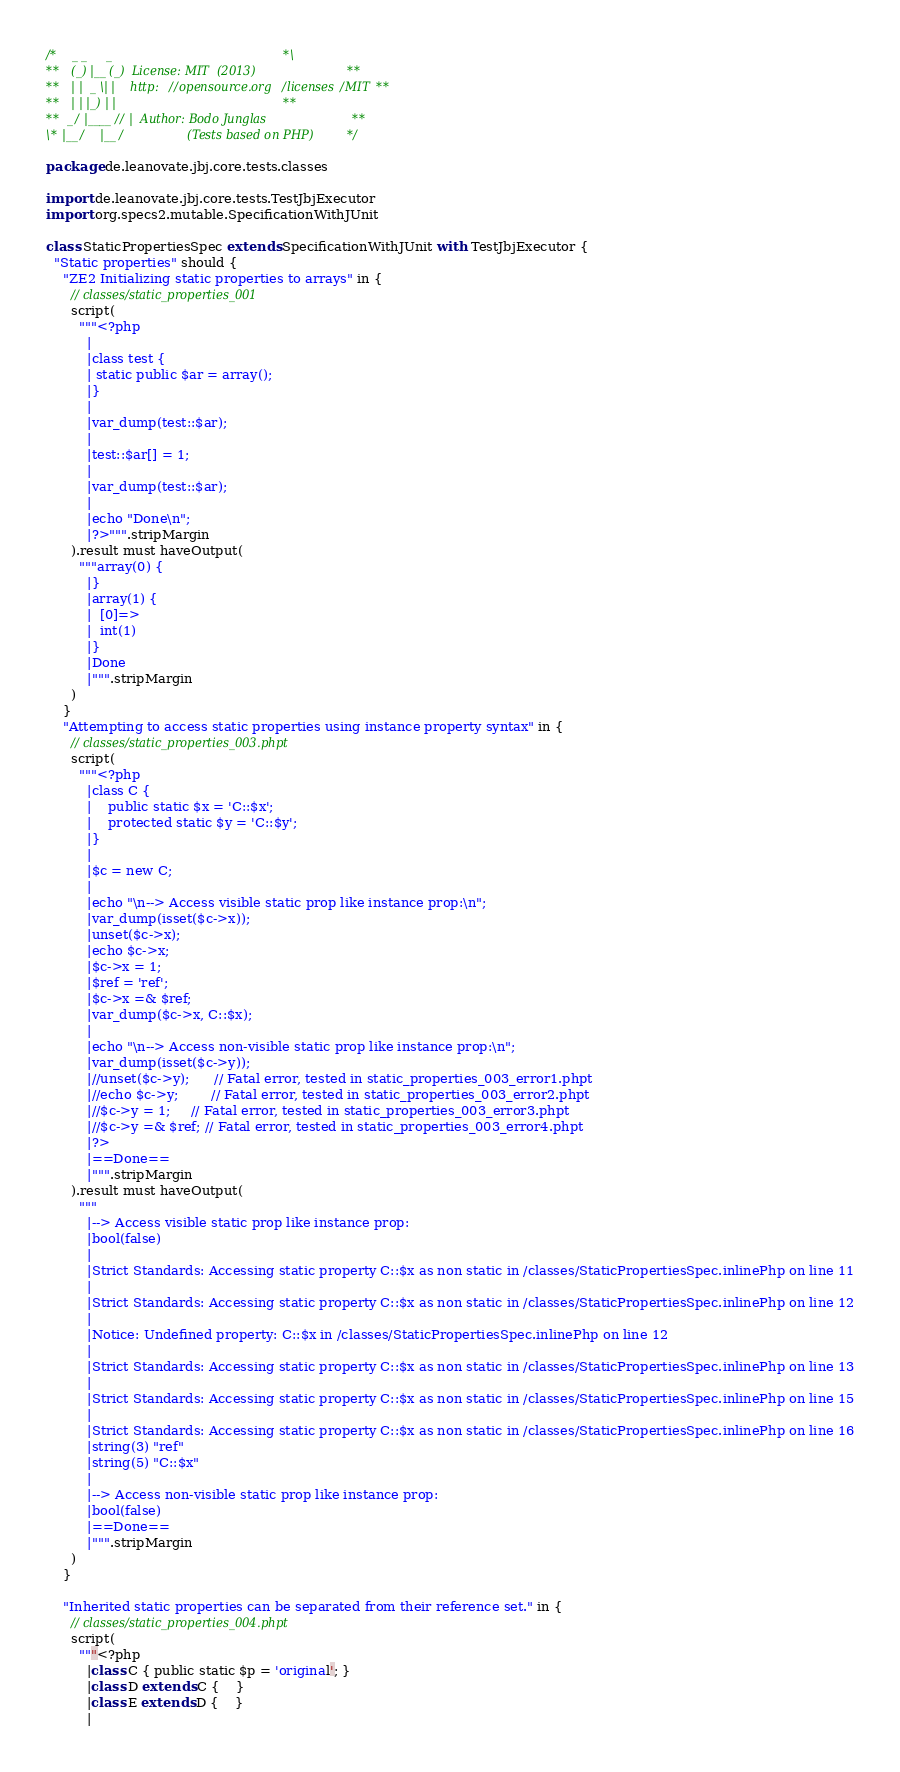<code> <loc_0><loc_0><loc_500><loc_500><_Scala_>/*    _ _     _                                        *\
**   (_) |__ (_)  License: MIT  (2013)                 **
**   | |  _ \| |    http://opensource.org/licenses/MIT **
**   | | |_) | |                                       **
**  _/ |____// |  Author: Bodo Junglas                 **
\* |__/    |__/                 (Tests based on PHP)   */

package de.leanovate.jbj.core.tests.classes

import de.leanovate.jbj.core.tests.TestJbjExecutor
import org.specs2.mutable.SpecificationWithJUnit

class StaticPropertiesSpec extends SpecificationWithJUnit with TestJbjExecutor {
  "Static properties" should {
    "ZE2 Initializing static properties to arrays" in {
      // classes/static_properties_001
      script(
        """<?php
          |
          |class test {
          |	static public $ar = array();
          |}
          |
          |var_dump(test::$ar);
          |
          |test::$ar[] = 1;
          |
          |var_dump(test::$ar);
          |
          |echo "Done\n";
          |?>""".stripMargin
      ).result must haveOutput(
        """array(0) {
          |}
          |array(1) {
          |  [0]=>
          |  int(1)
          |}
          |Done
          |""".stripMargin
      )
    }
    "Attempting to access static properties using instance property syntax" in {
      // classes/static_properties_003.phpt
      script(
        """<?php
          |class C {
          |    public static $x = 'C::$x';
          |    protected static $y = 'C::$y';
          |}
          |
          |$c = new C;
          |
          |echo "\n--> Access visible static prop like instance prop:\n";
          |var_dump(isset($c->x));
          |unset($c->x);
          |echo $c->x;
          |$c->x = 1;
          |$ref = 'ref';
          |$c->x =& $ref;
          |var_dump($c->x, C::$x);
          |
          |echo "\n--> Access non-visible static prop like instance prop:\n";
          |var_dump(isset($c->y));
          |//unset($c->y);		// Fatal error, tested in static_properties_003_error1.phpt
          |//echo $c->y;		// Fatal error, tested in static_properties_003_error2.phpt
          |//$c->y = 1;		// Fatal error, tested in static_properties_003_error3.phpt
          |//$c->y =& $ref;	// Fatal error, tested in static_properties_003_error4.phpt
          |?>
          |==Done==
          |""".stripMargin
      ).result must haveOutput(
        """
          |--> Access visible static prop like instance prop:
          |bool(false)
          |
          |Strict Standards: Accessing static property C::$x as non static in /classes/StaticPropertiesSpec.inlinePhp on line 11
          |
          |Strict Standards: Accessing static property C::$x as non static in /classes/StaticPropertiesSpec.inlinePhp on line 12
          |
          |Notice: Undefined property: C::$x in /classes/StaticPropertiesSpec.inlinePhp on line 12
          |
          |Strict Standards: Accessing static property C::$x as non static in /classes/StaticPropertiesSpec.inlinePhp on line 13
          |
          |Strict Standards: Accessing static property C::$x as non static in /classes/StaticPropertiesSpec.inlinePhp on line 15
          |
          |Strict Standards: Accessing static property C::$x as non static in /classes/StaticPropertiesSpec.inlinePhp on line 16
          |string(3) "ref"
          |string(5) "C::$x"
          |
          |--> Access non-visible static prop like instance prop:
          |bool(false)
          |==Done==
          |""".stripMargin
      )
    }

    "Inherited static properties can be separated from their reference set." in {
      // classes/static_properties_004.phpt
      script(
        """<?php
          |class C { public static $p = 'original'; }
          |class D extends C {	}
          |class E extends D {	}
          |</code> 